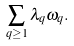<formula> <loc_0><loc_0><loc_500><loc_500>\sum _ { q \geq 1 } \lambda _ { q } \omega _ { q } .</formula> 